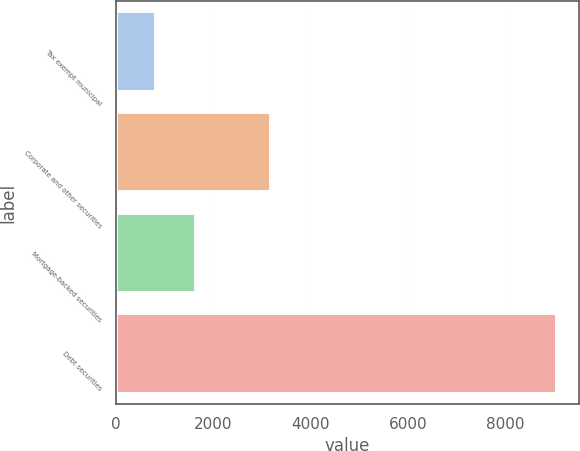Convert chart. <chart><loc_0><loc_0><loc_500><loc_500><bar_chart><fcel>Tax exempt municipal<fcel>Corporate and other securities<fcel>Mortgage-backed securities<fcel>Debt securities<nl><fcel>831<fcel>3198<fcel>1655<fcel>9071<nl></chart> 